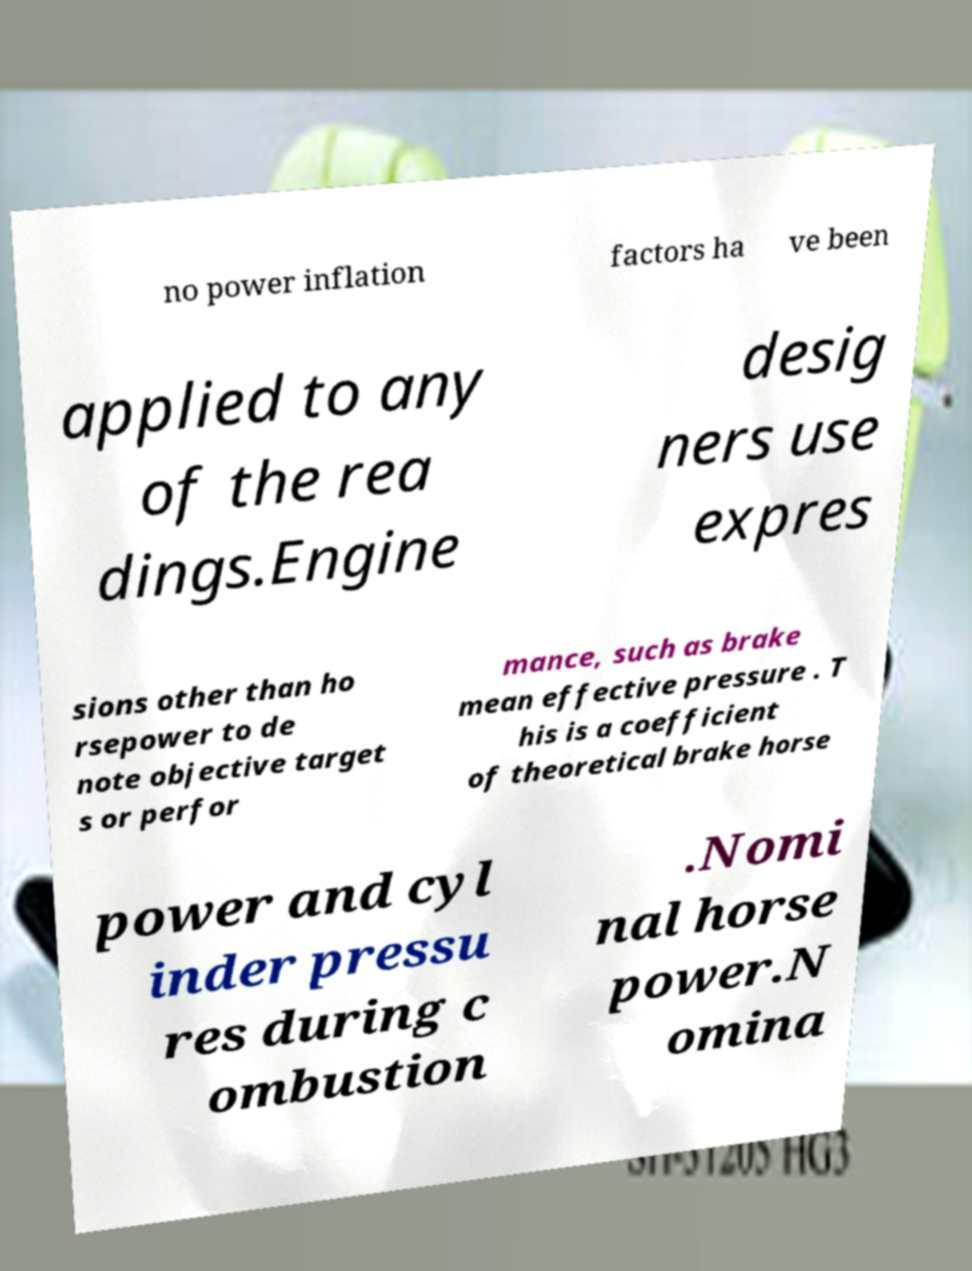Please read and relay the text visible in this image. What does it say? no power inflation factors ha ve been applied to any of the rea dings.Engine desig ners use expres sions other than ho rsepower to de note objective target s or perfor mance, such as brake mean effective pressure . T his is a coefficient of theoretical brake horse power and cyl inder pressu res during c ombustion .Nomi nal horse power.N omina 